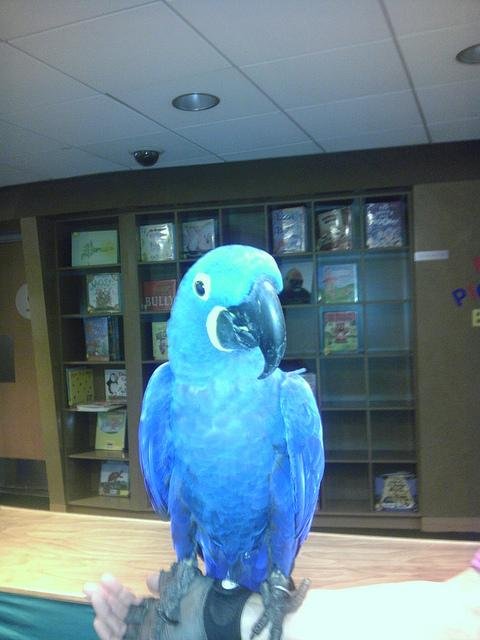Why is the person holding the bird wearing a glove? Please explain your reasoning. protection. This glove is probably to protect the wearers wrist and hand from the parrots claws. 